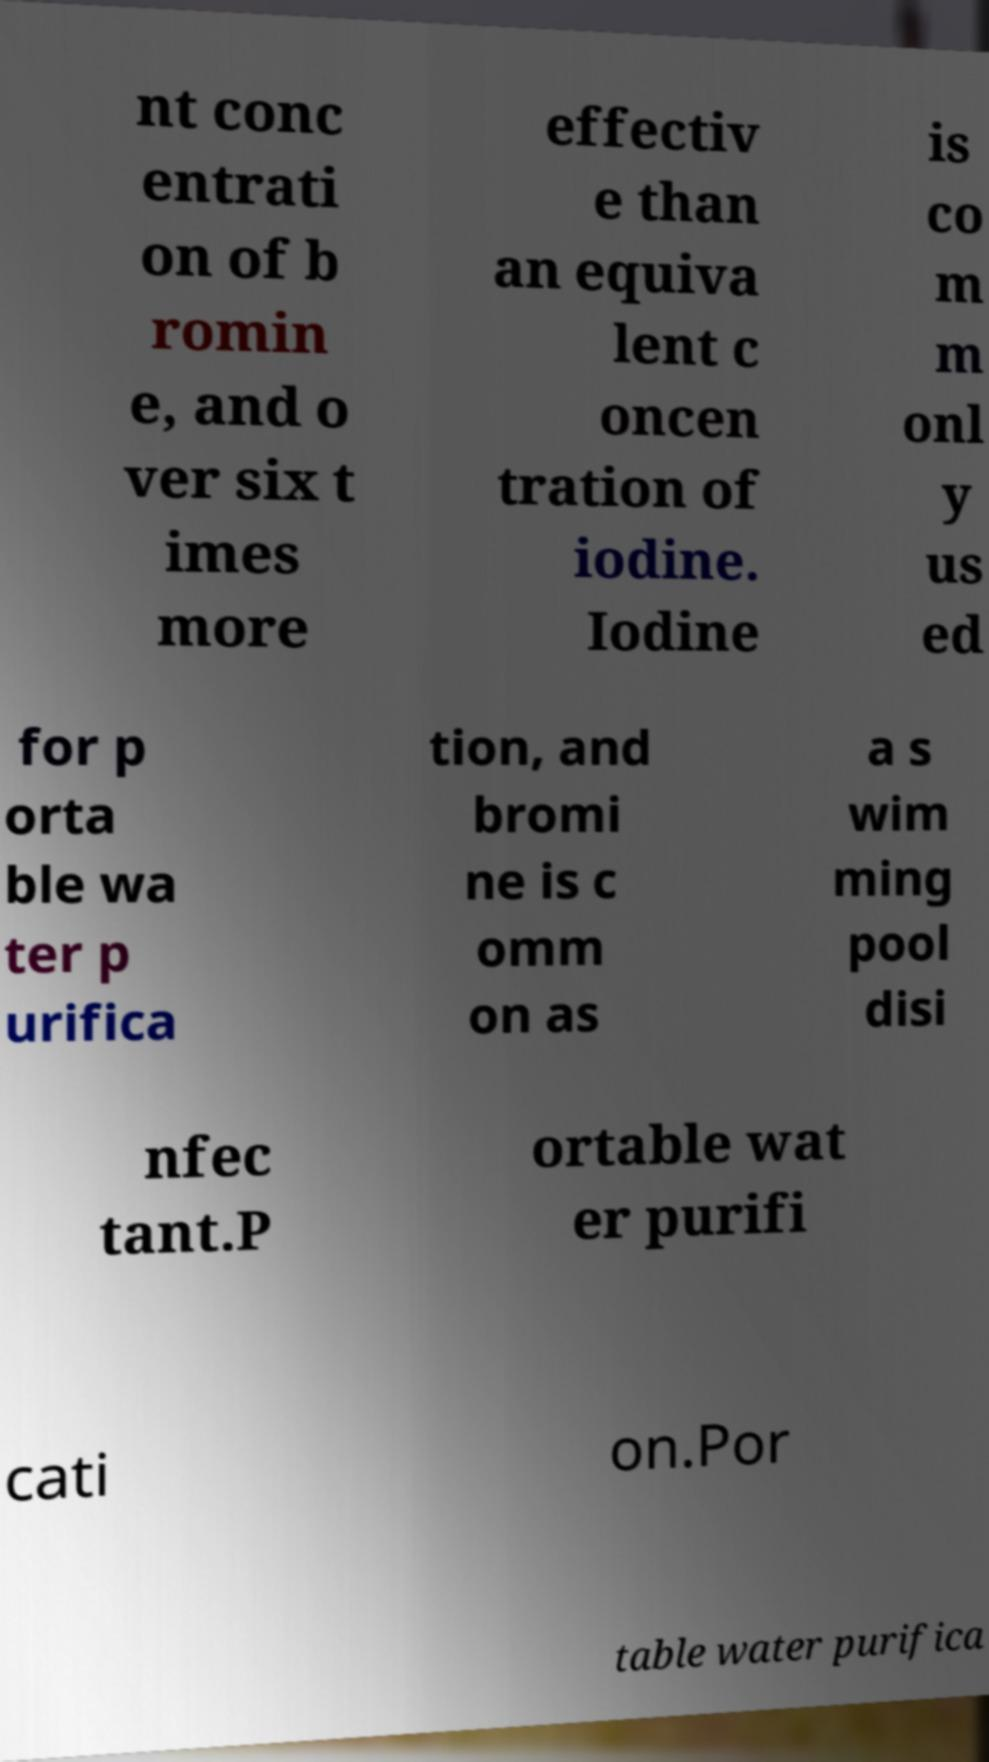I need the written content from this picture converted into text. Can you do that? nt conc entrati on of b romin e, and o ver six t imes more effectiv e than an equiva lent c oncen tration of iodine. Iodine is co m m onl y us ed for p orta ble wa ter p urifica tion, and bromi ne is c omm on as a s wim ming pool disi nfec tant.P ortable wat er purifi cati on.Por table water purifica 